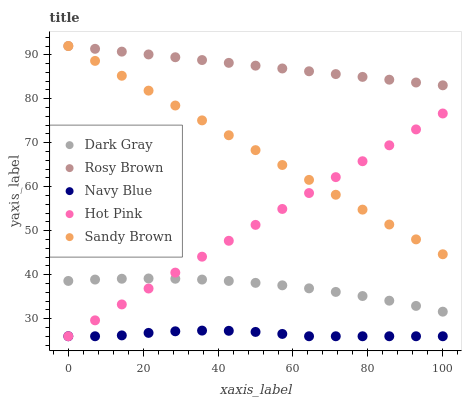Does Navy Blue have the minimum area under the curve?
Answer yes or no. Yes. Does Rosy Brown have the maximum area under the curve?
Answer yes or no. Yes. Does Rosy Brown have the minimum area under the curve?
Answer yes or no. No. Does Navy Blue have the maximum area under the curve?
Answer yes or no. No. Is Sandy Brown the smoothest?
Answer yes or no. Yes. Is Navy Blue the roughest?
Answer yes or no. Yes. Is Rosy Brown the smoothest?
Answer yes or no. No. Is Rosy Brown the roughest?
Answer yes or no. No. Does Navy Blue have the lowest value?
Answer yes or no. Yes. Does Rosy Brown have the lowest value?
Answer yes or no. No. Does Sandy Brown have the highest value?
Answer yes or no. Yes. Does Navy Blue have the highest value?
Answer yes or no. No. Is Navy Blue less than Sandy Brown?
Answer yes or no. Yes. Is Sandy Brown greater than Dark Gray?
Answer yes or no. Yes. Does Hot Pink intersect Dark Gray?
Answer yes or no. Yes. Is Hot Pink less than Dark Gray?
Answer yes or no. No. Is Hot Pink greater than Dark Gray?
Answer yes or no. No. Does Navy Blue intersect Sandy Brown?
Answer yes or no. No. 